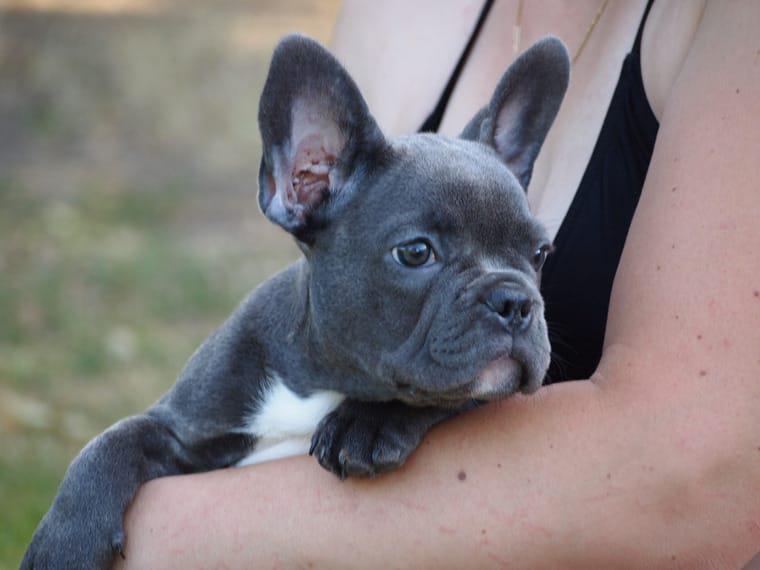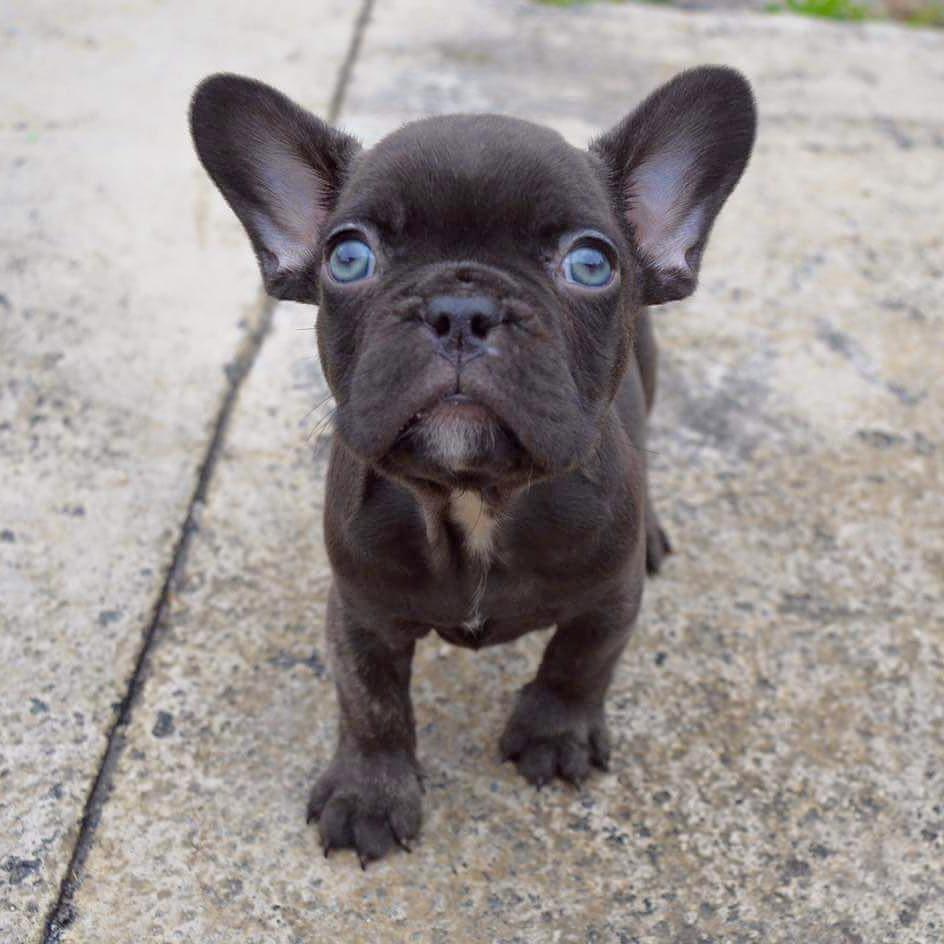The first image is the image on the left, the second image is the image on the right. For the images displayed, is the sentence "At least one dog is sleeping next to a human." factually correct? Answer yes or no. No. The first image is the image on the left, the second image is the image on the right. Analyze the images presented: Is the assertion "An adult human is holding one of the dogs." valid? Answer yes or no. Yes. 